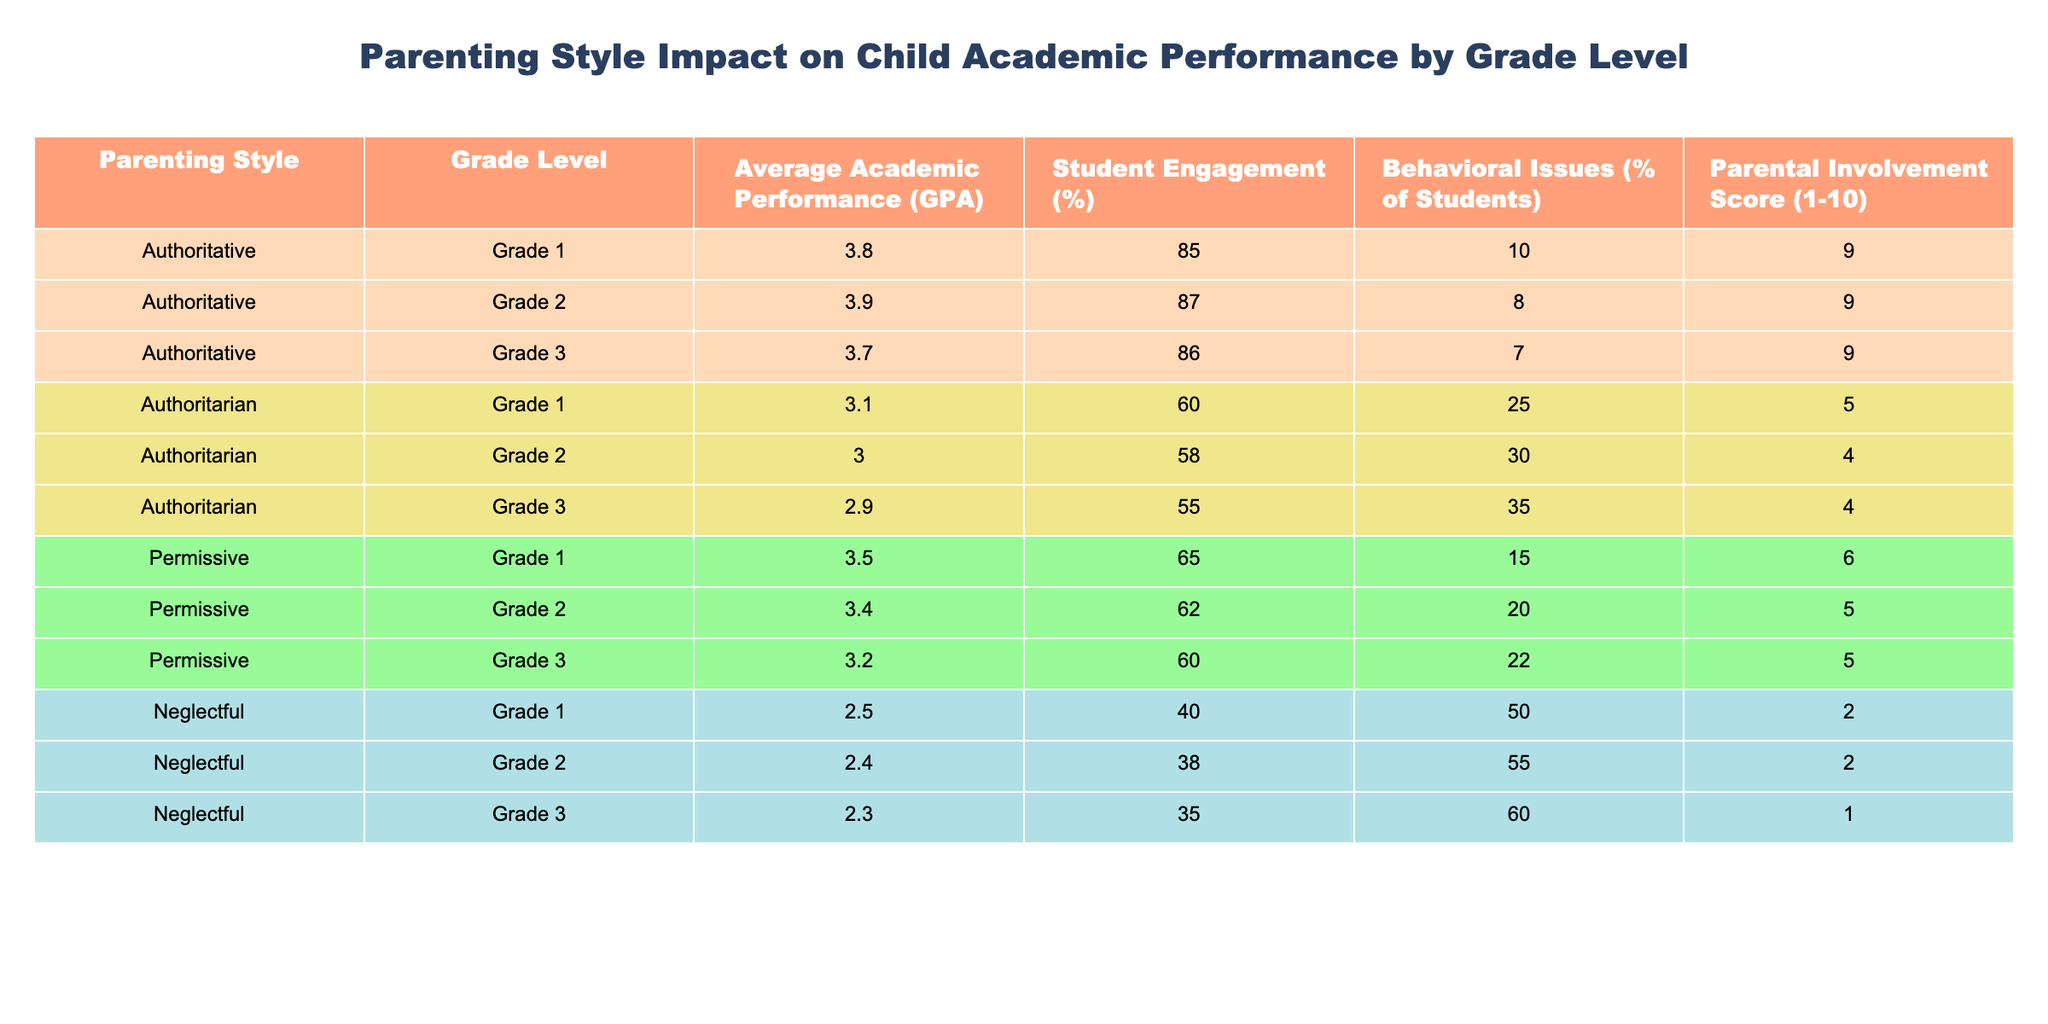What is the average GPA for children with authoritative parenting in Grade 2? The table shows that the average academic performance (GPA) for authoritative parenting in Grade 2 is 3.9.
Answer: 3.9 Which parenting style has the highest percentage of behavioral issues in Grade 3? According to the table, authoritarian parenting has the highest percentage of behavioral issues in Grade 3 at 35%.
Answer: Authoritarian How does the average GPA of neglectful parenting in Grade 1 compare to permissive parenting in Grade 1? The average GPA for neglectful parenting in Grade 1 is 2.5, while for permissive parenting it's 3.5. Thus, neglectful parenting has 1.0 point lower GPA than permissive parenting.
Answer: 1.0 point lower Calculate the average parental involvement score for all parenting styles across Grade 2. The parental involvement scores for Grade 2 are: Authoritative (9), Authoritarian (4), Permissive (5), and Neglectful (2). The sum is 9 + 4 + 5 + 2 = 20, and there are 4 scores, so the average is 20/4 = 5.
Answer: 5 Is it true that all grade levels with authoritative parenting have a higher average GPA than those with neglectful parenting? Looking at the table, the average GPAs for authoritative parenting across all grades are 3.8, 3.9, and 3.7, while for neglectful parenting they are 2.5, 2.4, and 2.3. Thus, it is true that authoritative averages are higher.
Answer: Yes What is the percentage of student engagement in Grade 3 for permissive parenting? The table indicates that the student engagement percentage for permissive parenting in Grade 3 is 60%.
Answer: 60% If we were to rank the parenting styles based on average GPA in Grade 1, which style would come first? The average GPAs for Grade 1 are: Authoritative (3.8), Permissive (3.5), Authoritarian (3.1), and Neglectful (2.5). Authoritative has the highest GPA, so it would come first in ranking.
Answer: Authoritative What is the total percentage of behavioral issues for both authoritarian and neglectful parenting styles in Grade 2? The table shows that authoritarian parenting has 30% and neglectful parenting has 55% incidence of behavioral issues for Grade 2. Adding these gives 30% + 55% = 85%.
Answer: 85% Which grade level shows the highest average GPA among the four parenting styles? The average GPAs are: Authoritative (3.9), Authoritarian (3.0), Permissive (3.4), Neglectful (2.4) for Grade 2. Therefore, Grade 2 has the highest average GPA of 3.9 under authoritative parenting.
Answer: Grade 2 In terms of parental involvement, which parenting style has the lowest score in Grade 3? The parental involvement scores for Grade 3 are: Authoritative (9), Authoritarian (4), Permissive (5), and Neglectful (1). Neglectful has the lowest score of 1.
Answer: Neglectful 